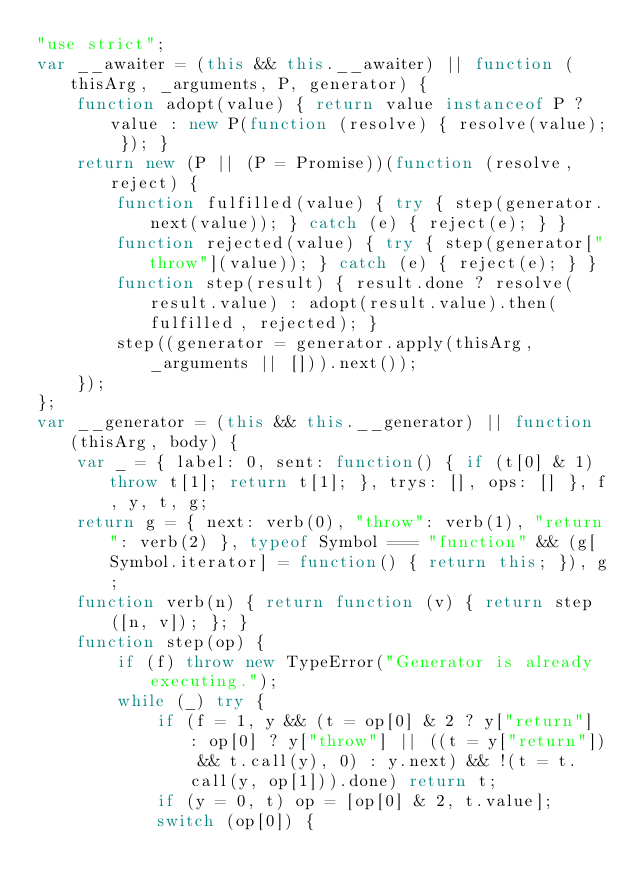<code> <loc_0><loc_0><loc_500><loc_500><_JavaScript_>"use strict";
var __awaiter = (this && this.__awaiter) || function (thisArg, _arguments, P, generator) {
    function adopt(value) { return value instanceof P ? value : new P(function (resolve) { resolve(value); }); }
    return new (P || (P = Promise))(function (resolve, reject) {
        function fulfilled(value) { try { step(generator.next(value)); } catch (e) { reject(e); } }
        function rejected(value) { try { step(generator["throw"](value)); } catch (e) { reject(e); } }
        function step(result) { result.done ? resolve(result.value) : adopt(result.value).then(fulfilled, rejected); }
        step((generator = generator.apply(thisArg, _arguments || [])).next());
    });
};
var __generator = (this && this.__generator) || function (thisArg, body) {
    var _ = { label: 0, sent: function() { if (t[0] & 1) throw t[1]; return t[1]; }, trys: [], ops: [] }, f, y, t, g;
    return g = { next: verb(0), "throw": verb(1), "return": verb(2) }, typeof Symbol === "function" && (g[Symbol.iterator] = function() { return this; }), g;
    function verb(n) { return function (v) { return step([n, v]); }; }
    function step(op) {
        if (f) throw new TypeError("Generator is already executing.");
        while (_) try {
            if (f = 1, y && (t = op[0] & 2 ? y["return"] : op[0] ? y["throw"] || ((t = y["return"]) && t.call(y), 0) : y.next) && !(t = t.call(y, op[1])).done) return t;
            if (y = 0, t) op = [op[0] & 2, t.value];
            switch (op[0]) {</code> 